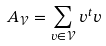<formula> <loc_0><loc_0><loc_500><loc_500>A _ { \mathcal { V } } = \sum _ { v \in { \mathcal { V } } } v ^ { t } v</formula> 